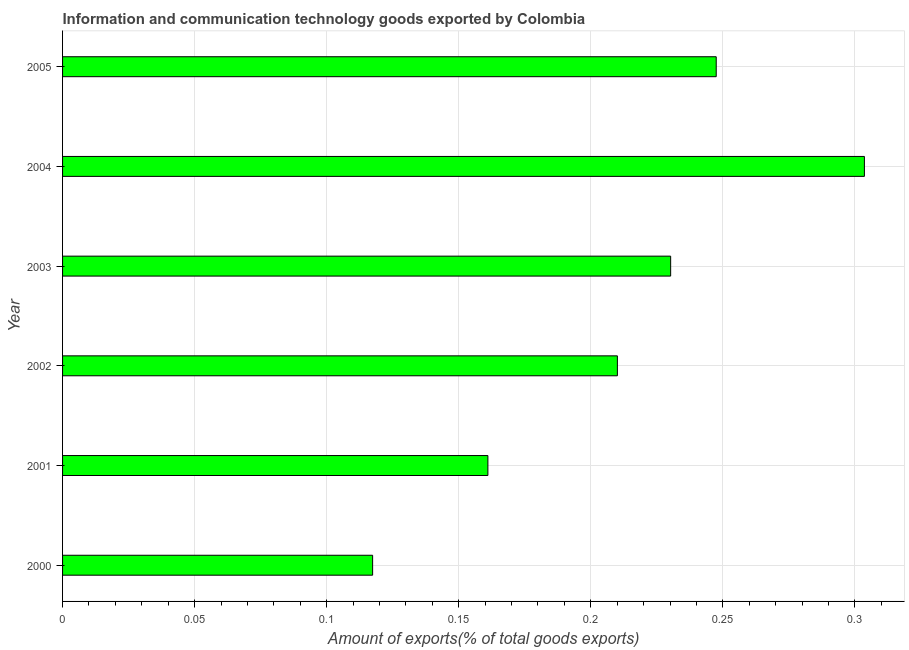What is the title of the graph?
Your answer should be very brief. Information and communication technology goods exported by Colombia. What is the label or title of the X-axis?
Your answer should be compact. Amount of exports(% of total goods exports). What is the label or title of the Y-axis?
Keep it short and to the point. Year. What is the amount of ict goods exports in 2002?
Your response must be concise. 0.21. Across all years, what is the maximum amount of ict goods exports?
Offer a very short reply. 0.3. Across all years, what is the minimum amount of ict goods exports?
Your answer should be very brief. 0.12. In which year was the amount of ict goods exports maximum?
Give a very brief answer. 2004. What is the sum of the amount of ict goods exports?
Provide a short and direct response. 1.27. What is the difference between the amount of ict goods exports in 2000 and 2005?
Provide a short and direct response. -0.13. What is the average amount of ict goods exports per year?
Make the answer very short. 0.21. What is the median amount of ict goods exports?
Offer a very short reply. 0.22. In how many years, is the amount of ict goods exports greater than 0.06 %?
Your answer should be compact. 6. Do a majority of the years between 2003 and 2000 (inclusive) have amount of ict goods exports greater than 0.14 %?
Your answer should be very brief. Yes. What is the ratio of the amount of ict goods exports in 2004 to that in 2005?
Your answer should be very brief. 1.23. Is the amount of ict goods exports in 2000 less than that in 2001?
Your answer should be very brief. Yes. What is the difference between the highest and the second highest amount of ict goods exports?
Provide a succinct answer. 0.06. What is the difference between the highest and the lowest amount of ict goods exports?
Offer a terse response. 0.19. In how many years, is the amount of ict goods exports greater than the average amount of ict goods exports taken over all years?
Offer a very short reply. 3. How many bars are there?
Offer a terse response. 6. Are the values on the major ticks of X-axis written in scientific E-notation?
Offer a terse response. No. What is the Amount of exports(% of total goods exports) of 2000?
Give a very brief answer. 0.12. What is the Amount of exports(% of total goods exports) in 2001?
Your answer should be very brief. 0.16. What is the Amount of exports(% of total goods exports) of 2002?
Your response must be concise. 0.21. What is the Amount of exports(% of total goods exports) of 2003?
Offer a very short reply. 0.23. What is the Amount of exports(% of total goods exports) in 2004?
Offer a very short reply. 0.3. What is the Amount of exports(% of total goods exports) of 2005?
Give a very brief answer. 0.25. What is the difference between the Amount of exports(% of total goods exports) in 2000 and 2001?
Give a very brief answer. -0.04. What is the difference between the Amount of exports(% of total goods exports) in 2000 and 2002?
Offer a terse response. -0.09. What is the difference between the Amount of exports(% of total goods exports) in 2000 and 2003?
Keep it short and to the point. -0.11. What is the difference between the Amount of exports(% of total goods exports) in 2000 and 2004?
Make the answer very short. -0.19. What is the difference between the Amount of exports(% of total goods exports) in 2000 and 2005?
Your answer should be compact. -0.13. What is the difference between the Amount of exports(% of total goods exports) in 2001 and 2002?
Keep it short and to the point. -0.05. What is the difference between the Amount of exports(% of total goods exports) in 2001 and 2003?
Your answer should be compact. -0.07. What is the difference between the Amount of exports(% of total goods exports) in 2001 and 2004?
Provide a short and direct response. -0.14. What is the difference between the Amount of exports(% of total goods exports) in 2001 and 2005?
Provide a succinct answer. -0.09. What is the difference between the Amount of exports(% of total goods exports) in 2002 and 2003?
Give a very brief answer. -0.02. What is the difference between the Amount of exports(% of total goods exports) in 2002 and 2004?
Offer a terse response. -0.09. What is the difference between the Amount of exports(% of total goods exports) in 2002 and 2005?
Ensure brevity in your answer.  -0.04. What is the difference between the Amount of exports(% of total goods exports) in 2003 and 2004?
Your answer should be very brief. -0.07. What is the difference between the Amount of exports(% of total goods exports) in 2003 and 2005?
Offer a very short reply. -0.02. What is the difference between the Amount of exports(% of total goods exports) in 2004 and 2005?
Provide a succinct answer. 0.06. What is the ratio of the Amount of exports(% of total goods exports) in 2000 to that in 2001?
Offer a terse response. 0.73. What is the ratio of the Amount of exports(% of total goods exports) in 2000 to that in 2002?
Your response must be concise. 0.56. What is the ratio of the Amount of exports(% of total goods exports) in 2000 to that in 2003?
Your response must be concise. 0.51. What is the ratio of the Amount of exports(% of total goods exports) in 2000 to that in 2004?
Your answer should be compact. 0.39. What is the ratio of the Amount of exports(% of total goods exports) in 2000 to that in 2005?
Your answer should be compact. 0.47. What is the ratio of the Amount of exports(% of total goods exports) in 2001 to that in 2002?
Offer a very short reply. 0.77. What is the ratio of the Amount of exports(% of total goods exports) in 2001 to that in 2003?
Your answer should be compact. 0.7. What is the ratio of the Amount of exports(% of total goods exports) in 2001 to that in 2004?
Your answer should be very brief. 0.53. What is the ratio of the Amount of exports(% of total goods exports) in 2001 to that in 2005?
Make the answer very short. 0.65. What is the ratio of the Amount of exports(% of total goods exports) in 2002 to that in 2003?
Provide a short and direct response. 0.91. What is the ratio of the Amount of exports(% of total goods exports) in 2002 to that in 2004?
Provide a short and direct response. 0.69. What is the ratio of the Amount of exports(% of total goods exports) in 2002 to that in 2005?
Keep it short and to the point. 0.85. What is the ratio of the Amount of exports(% of total goods exports) in 2003 to that in 2004?
Keep it short and to the point. 0.76. What is the ratio of the Amount of exports(% of total goods exports) in 2004 to that in 2005?
Offer a terse response. 1.23. 